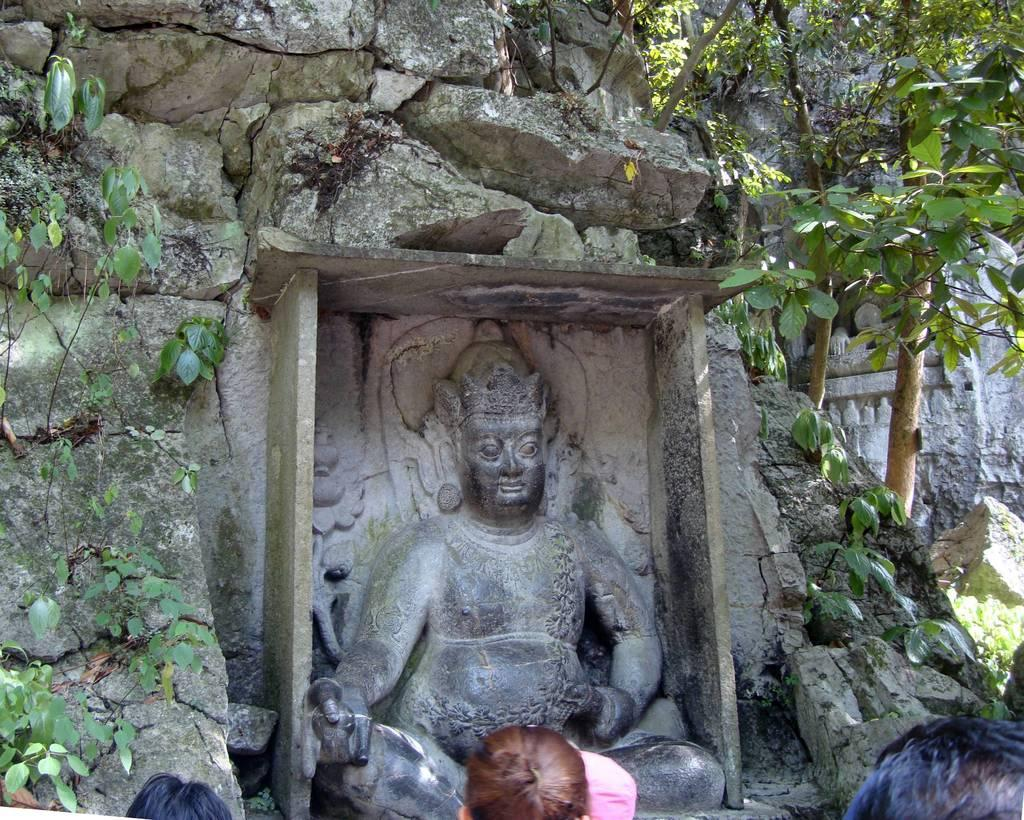What type of art is present in the image? There are sculptures in the image. What natural elements can be seen in the image? There are rocks and trees in the image. Are there any human elements in the image? Yes, the heads of people are visible at the bottom of the image. What type of chair is depicted in the image? There is no chair present in the image. What rule is being enforced by the sculptures in the image? The sculptures in the image are not enforcing any rules; they are artistic creations. 